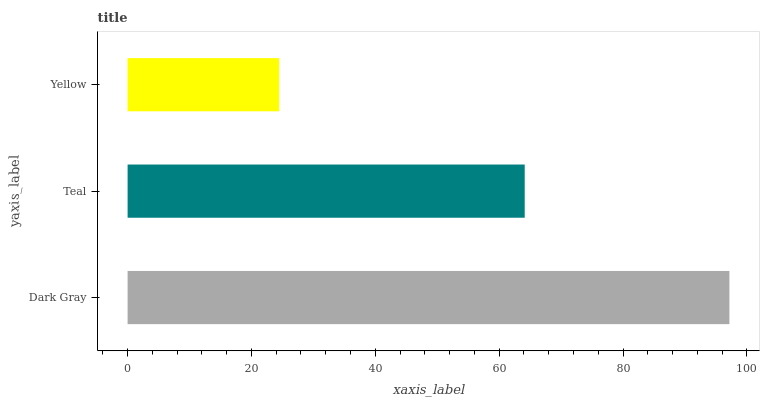Is Yellow the minimum?
Answer yes or no. Yes. Is Dark Gray the maximum?
Answer yes or no. Yes. Is Teal the minimum?
Answer yes or no. No. Is Teal the maximum?
Answer yes or no. No. Is Dark Gray greater than Teal?
Answer yes or no. Yes. Is Teal less than Dark Gray?
Answer yes or no. Yes. Is Teal greater than Dark Gray?
Answer yes or no. No. Is Dark Gray less than Teal?
Answer yes or no. No. Is Teal the high median?
Answer yes or no. Yes. Is Teal the low median?
Answer yes or no. Yes. Is Dark Gray the high median?
Answer yes or no. No. Is Dark Gray the low median?
Answer yes or no. No. 